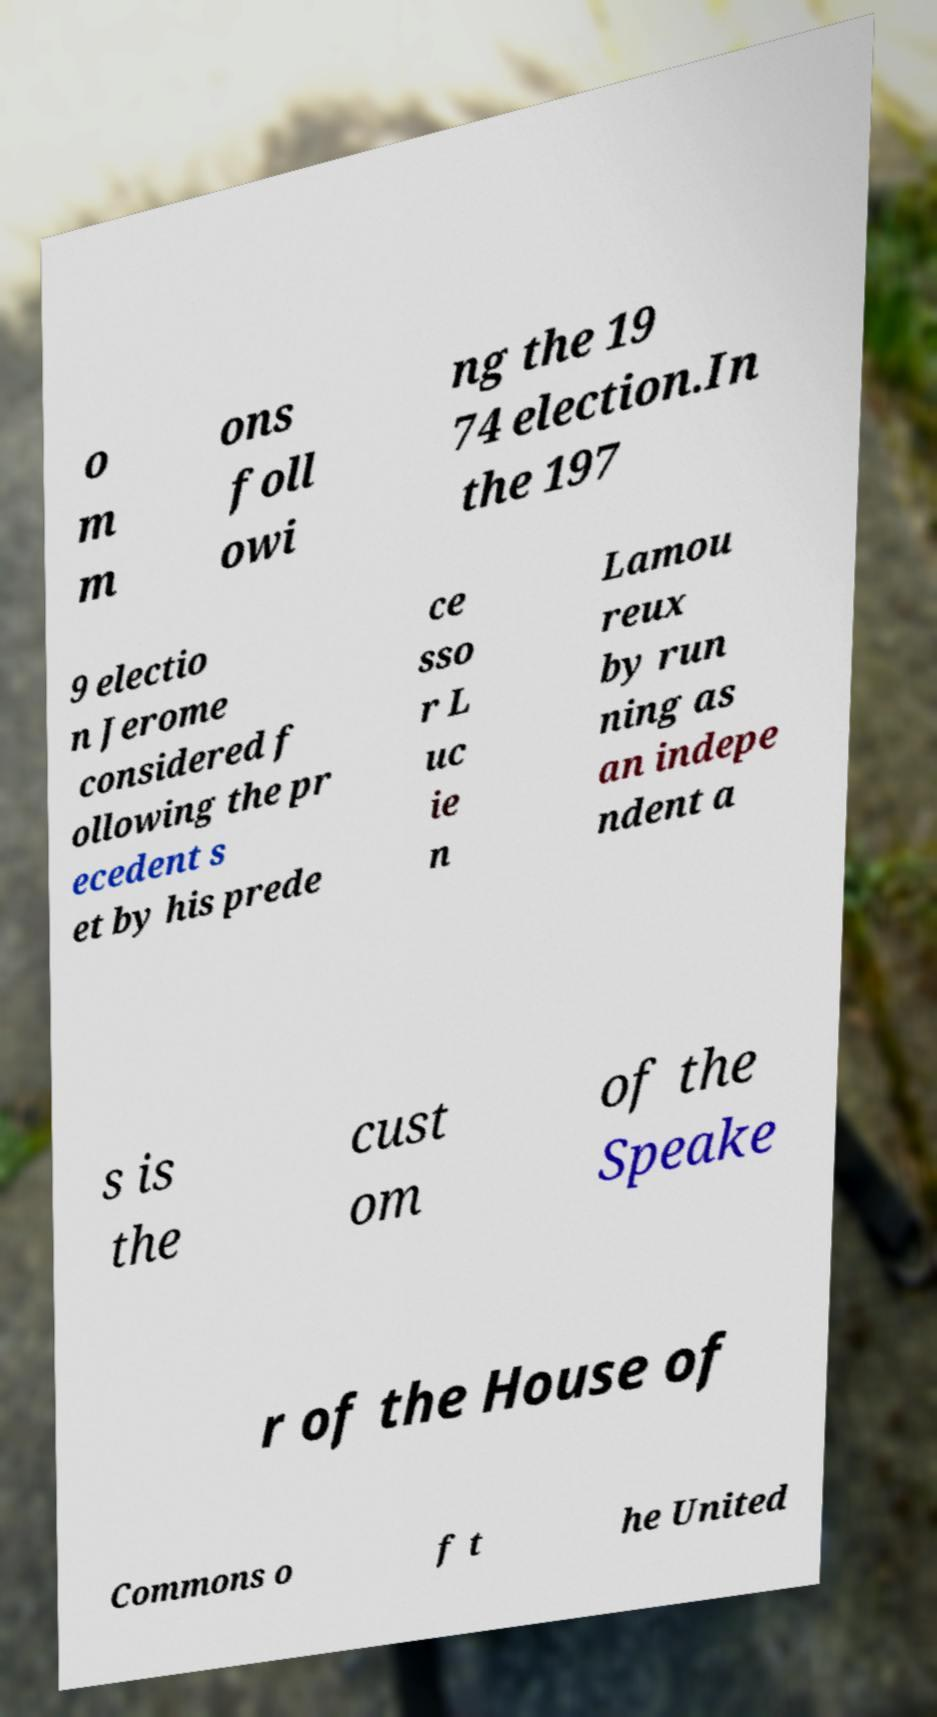What messages or text are displayed in this image? I need them in a readable, typed format. o m m ons foll owi ng the 19 74 election.In the 197 9 electio n Jerome considered f ollowing the pr ecedent s et by his prede ce sso r L uc ie n Lamou reux by run ning as an indepe ndent a s is the cust om of the Speake r of the House of Commons o f t he United 